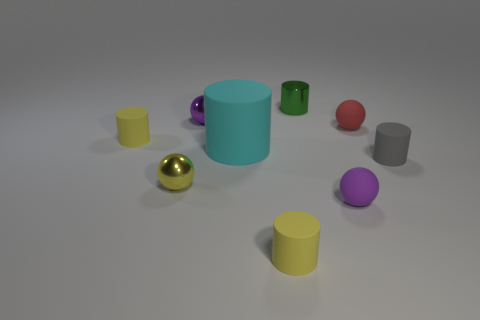What is the material of the red ball?
Keep it short and to the point. Rubber. Is the material of the tiny purple ball behind the red matte object the same as the purple object in front of the yellow ball?
Give a very brief answer. No. Do the tiny yellow matte object behind the purple matte ball and the large cyan object in front of the red object have the same shape?
Ensure brevity in your answer.  Yes. What is the color of the big thing that is the same material as the red ball?
Ensure brevity in your answer.  Cyan. Is the number of tiny yellow things that are on the left side of the green metallic thing less than the number of purple things?
Offer a very short reply. No. How big is the cyan matte cylinder that is to the right of the yellow cylinder that is behind the purple object that is on the right side of the green object?
Provide a short and direct response. Large. Do the small purple ball that is in front of the tiny red matte sphere and the tiny green thing have the same material?
Your answer should be compact. No. How many objects are gray things or tiny yellow rubber things?
Keep it short and to the point. 3. The cyan matte thing that is the same shape as the gray matte thing is what size?
Your answer should be compact. Large. Is there any other thing that has the same size as the cyan cylinder?
Your answer should be very brief. No. 